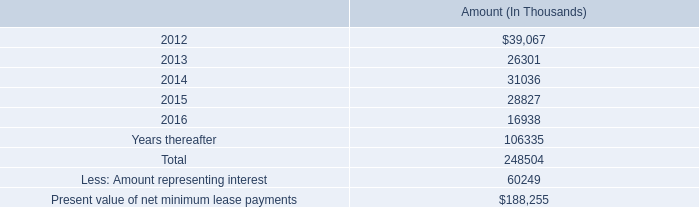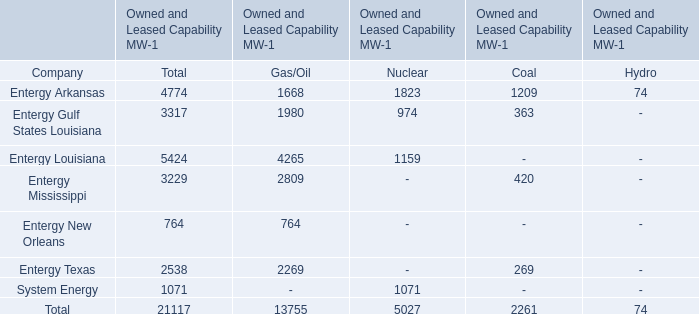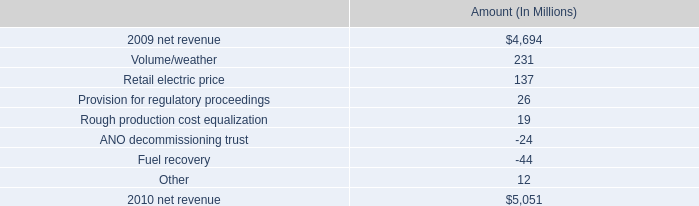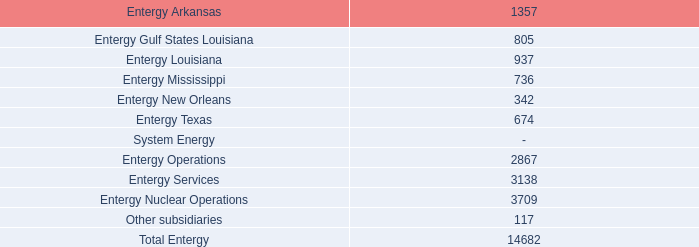what was the percentage change of the net revenue in 2010 
Computations: ((5051 - 4694) / 4694)
Answer: 0.07605. 